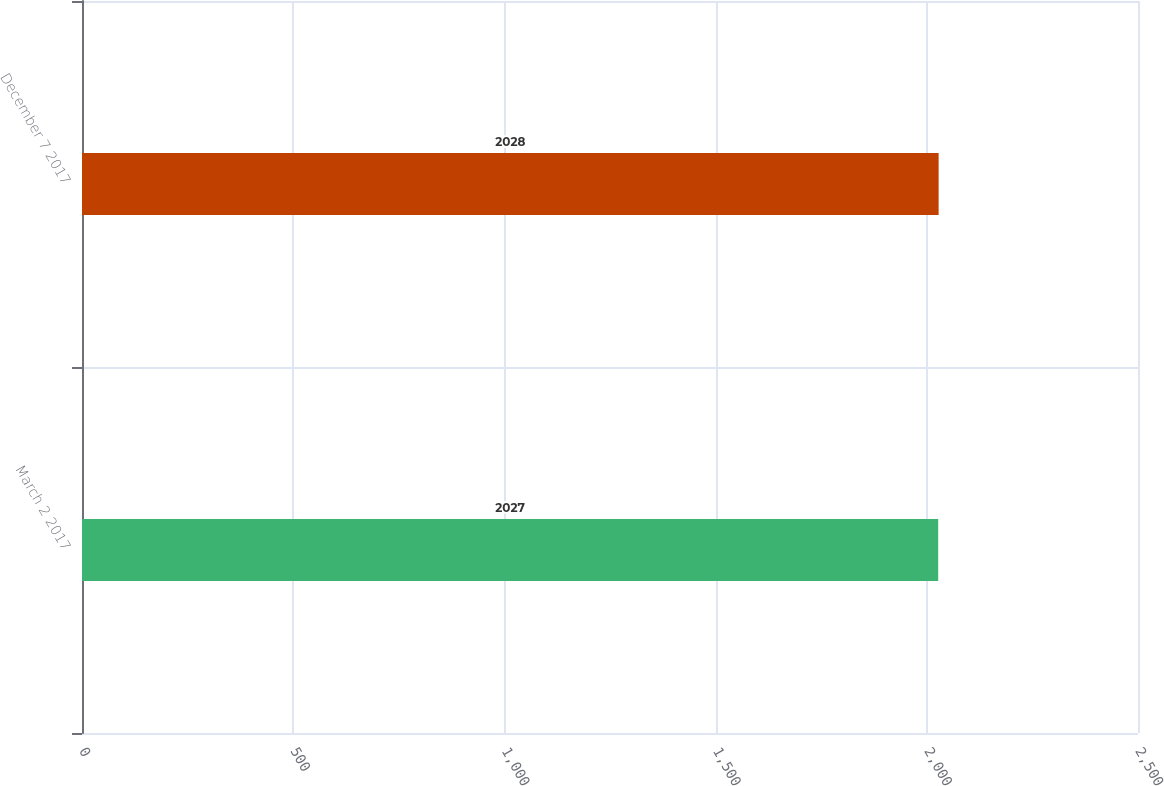<chart> <loc_0><loc_0><loc_500><loc_500><bar_chart><fcel>March 2 2017<fcel>December 7 2017<nl><fcel>2027<fcel>2028<nl></chart> 